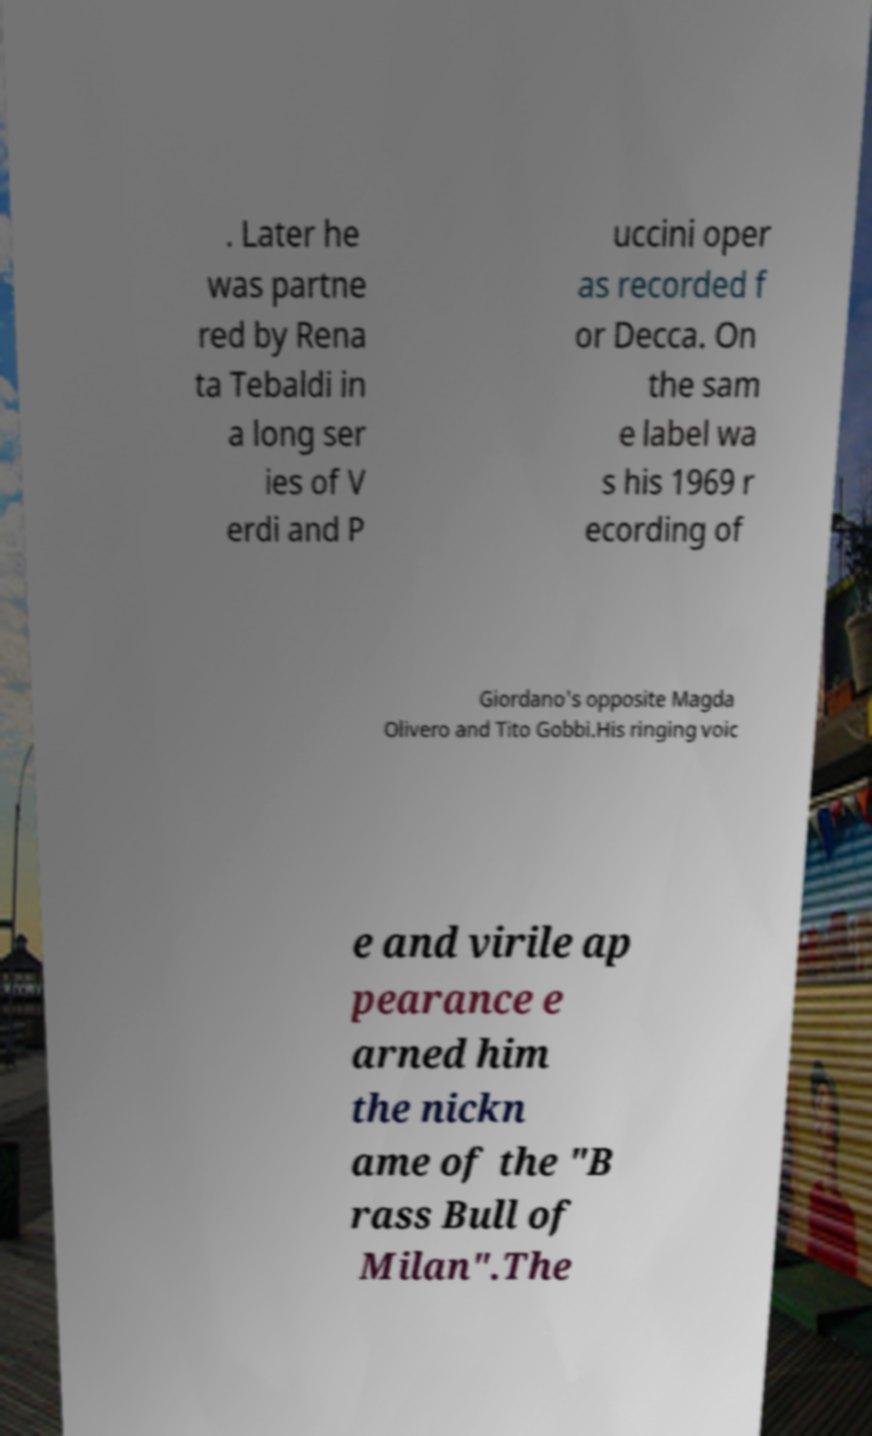Can you accurately transcribe the text from the provided image for me? . Later he was partne red by Rena ta Tebaldi in a long ser ies of V erdi and P uccini oper as recorded f or Decca. On the sam e label wa s his 1969 r ecording of Giordano's opposite Magda Olivero and Tito Gobbi.His ringing voic e and virile ap pearance e arned him the nickn ame of the "B rass Bull of Milan".The 